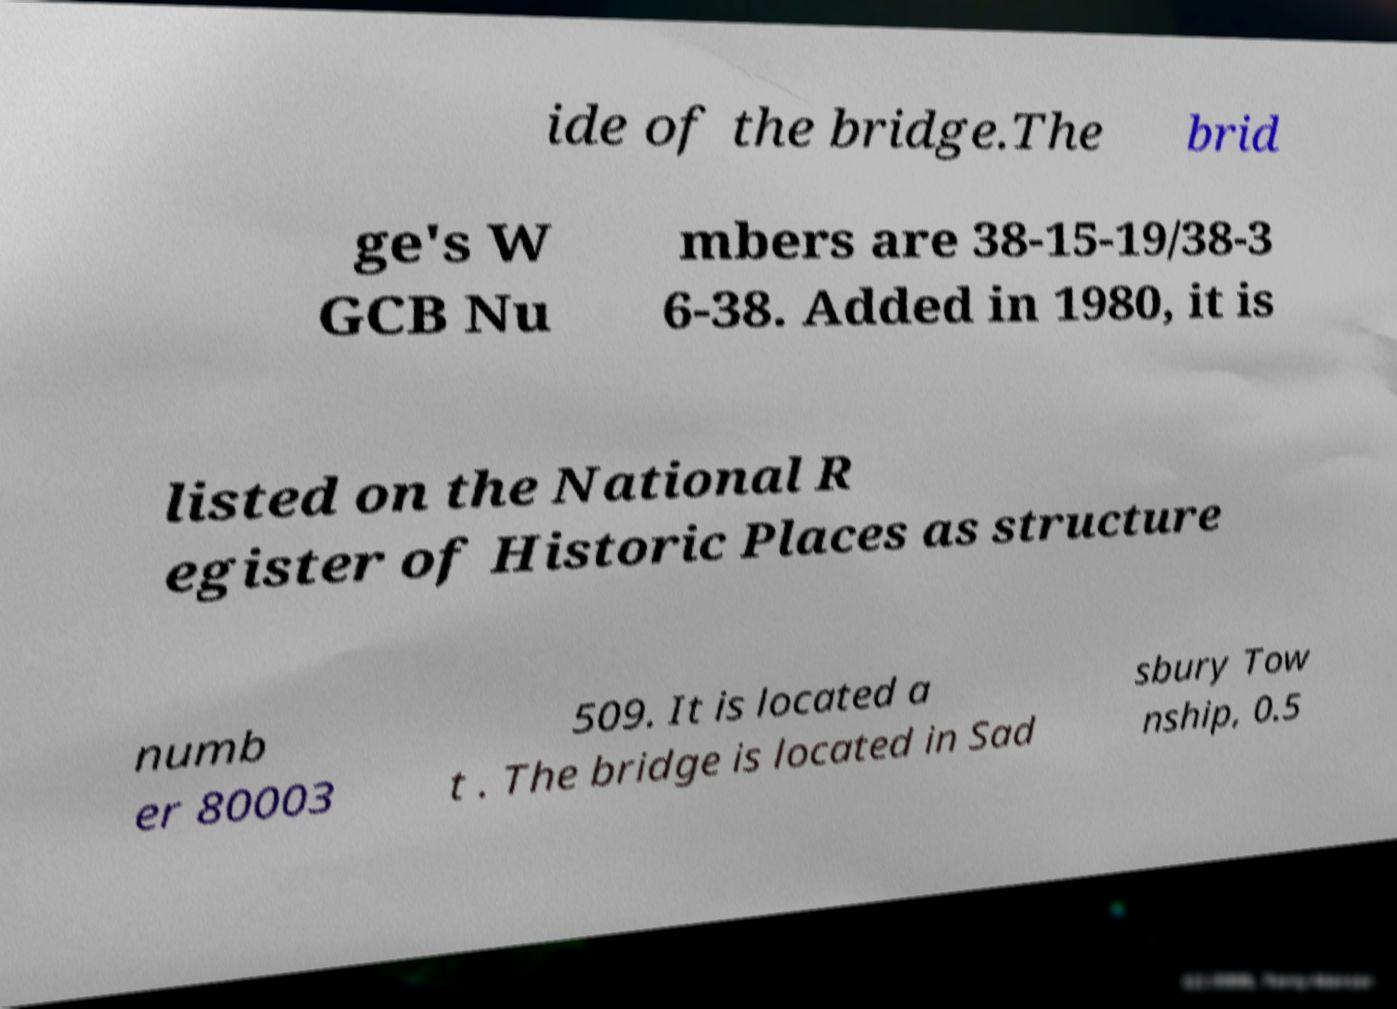For documentation purposes, I need the text within this image transcribed. Could you provide that? ide of the bridge.The brid ge's W GCB Nu mbers are 38-15-19/38-3 6-38. Added in 1980, it is listed on the National R egister of Historic Places as structure numb er 80003 509. It is located a t . The bridge is located in Sad sbury Tow nship, 0.5 